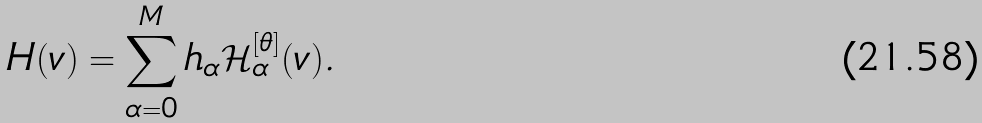Convert formula to latex. <formula><loc_0><loc_0><loc_500><loc_500>H ( v ) = \sum _ { \alpha = 0 } ^ { M } h _ { \alpha } \mathcal { H } ^ { [ \theta ] } _ { \alpha } ( v ) .</formula> 